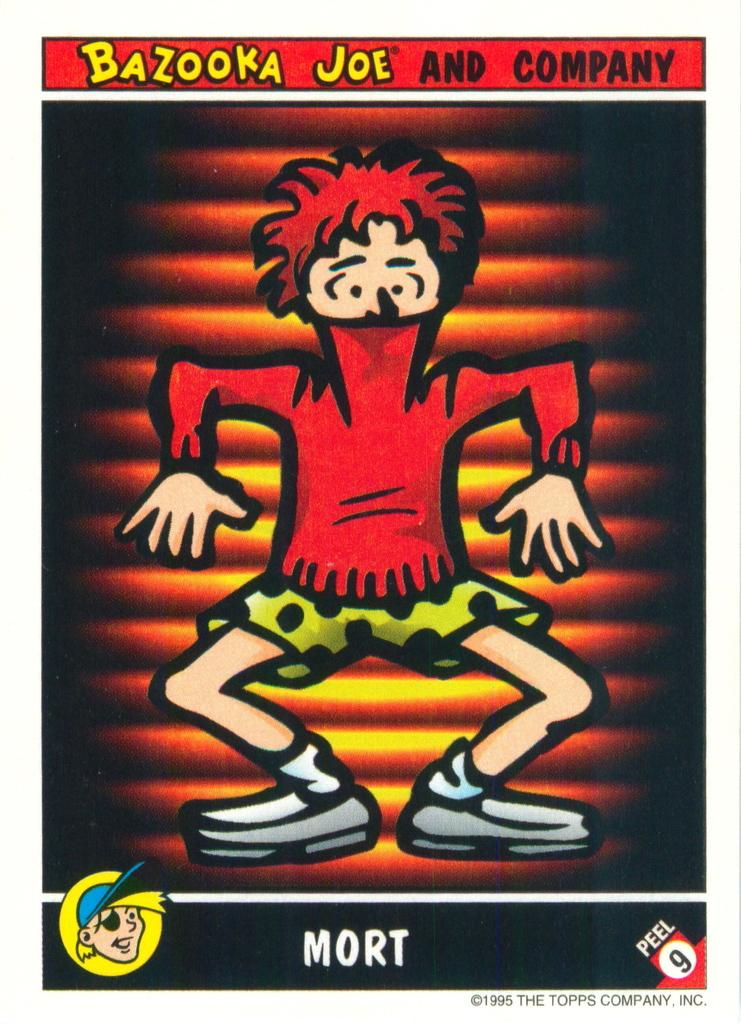What is the main object in the image? There is a poster in the image. What can be seen in the center of the poster? In the center of the poster, there is one person. Where is text located on the poster? There is text at the top and bottom of the poster. What type of polish is being applied to the branch in the image? There is no branch or polish present in the image; it only features a poster with a person and text. 